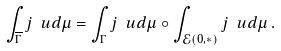Convert formula to latex. <formula><loc_0><loc_0><loc_500><loc_500>\int _ { \overline { \Gamma } } j \ u d \mu = \int _ { \Gamma } j \ u d \mu \circ \int _ { \mathcal { E } ( 0 , * ) } j \ u d \mu \, .</formula> 